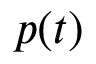Convert formula to latex. <formula><loc_0><loc_0><loc_500><loc_500>p ( t )</formula> 